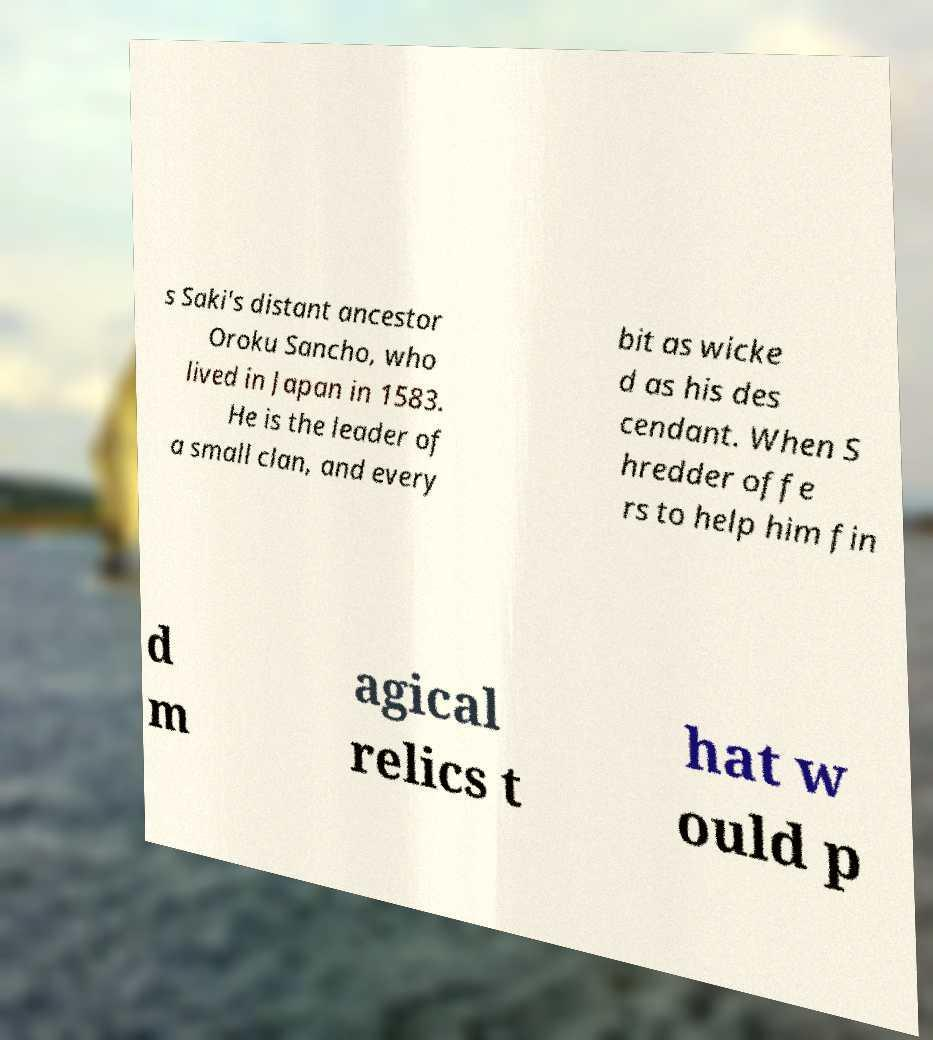Could you assist in decoding the text presented in this image and type it out clearly? s Saki's distant ancestor Oroku Sancho, who lived in Japan in 1583. He is the leader of a small clan, and every bit as wicke d as his des cendant. When S hredder offe rs to help him fin d m agical relics t hat w ould p 